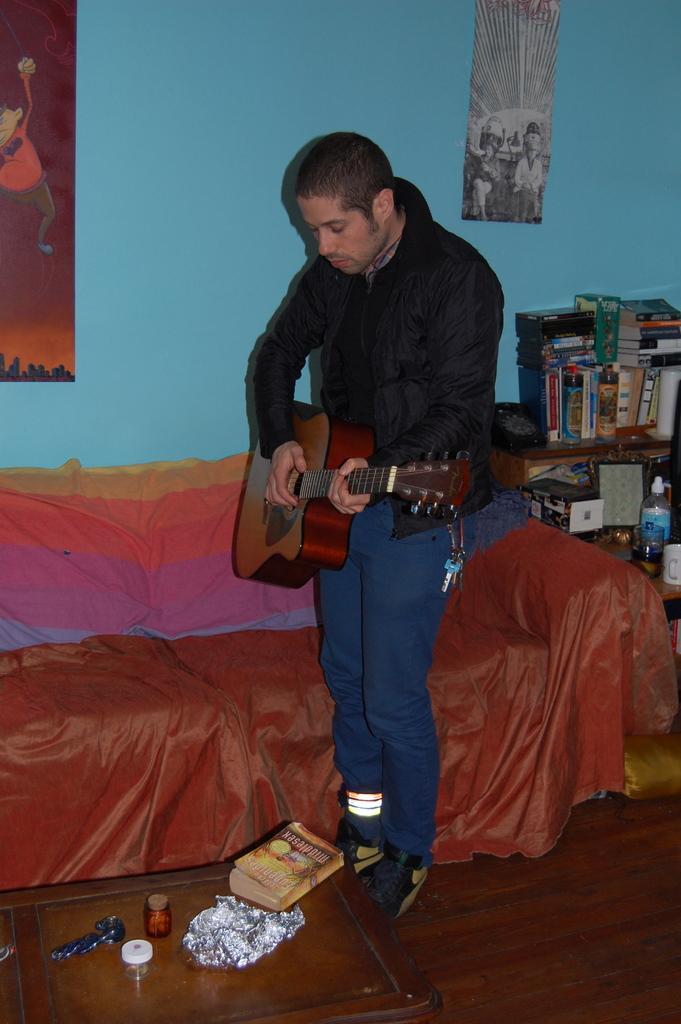Describe this image in one or two sentences. In this picture we have a person standing and playing a guitar in front of him there is a table on the table we have books and papers and back side we have one more table which is arranged so many books and bottles And right side of the person we can see a wall which is blue in color on the wall there to who painted papers are placed. 